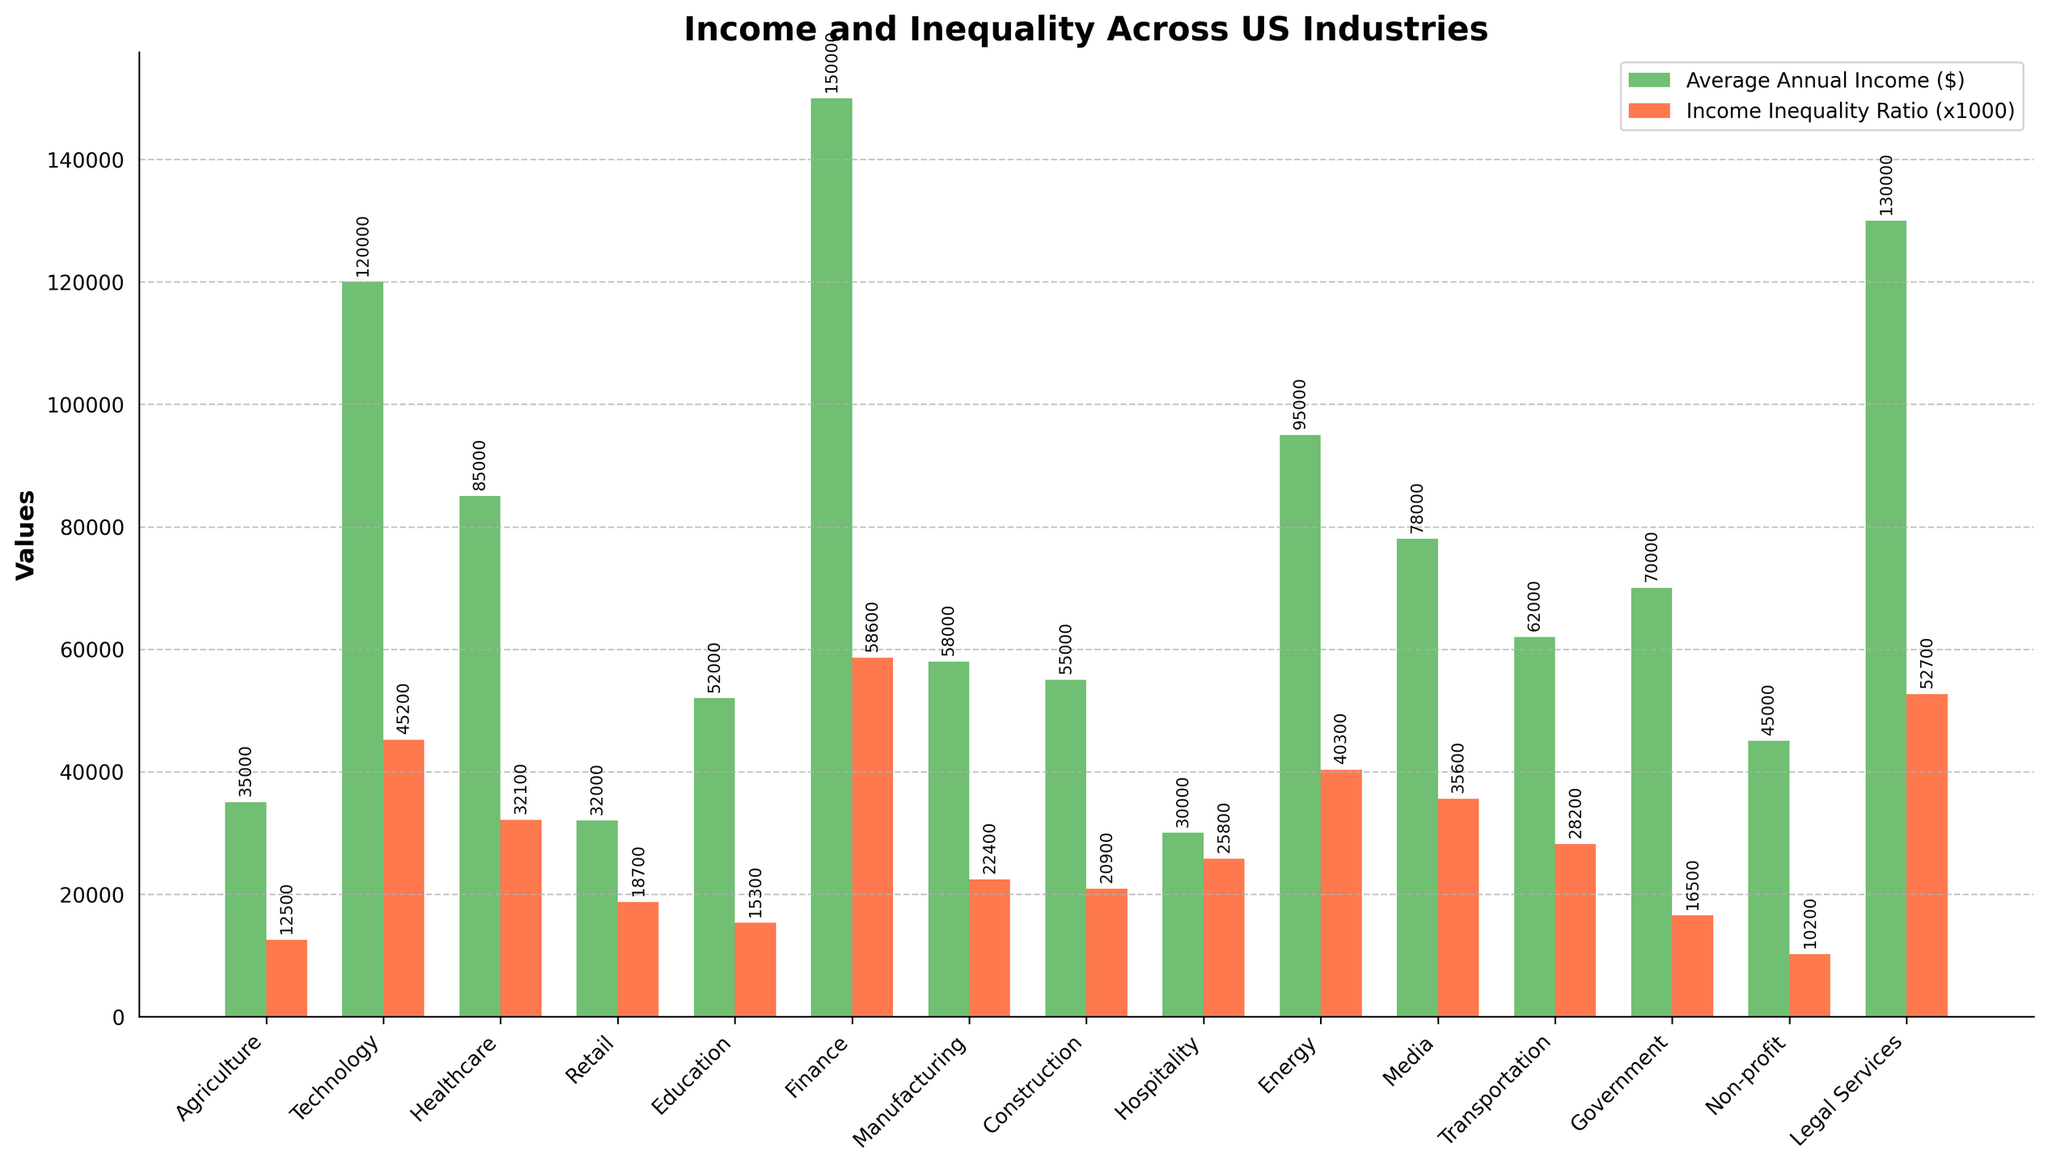Which industry has the highest average annual income? Look for the tallest green bar representing the average annual income. Technology industry has the highest bar indicating an average annual income of $120,000.
Answer: Technology Which industry shows the highest income inequality ratio? Look for the tallest red bar representing the income inequality ratio multiplied by 1000. Finance has the tallest red bar with an inequality ratio of 58.6.
Answer: Finance What is the difference in average annual income between the Technology and Retail industries? Find the green bars for Technology ($120,000) and Retail ($32,000), then subtract the Retail value from the Technology value. $120,000 - $32,000 = $88,000.
Answer: $88,000 Which industry has a higher income inequality, Energy or Media? Compare the heights of the red bars for Energy and Media. Energy's bar is higher with a ratio of 40.3, whereas Media has a ratio of 35.6.
Answer: Energy Is the income inequality ratio of Legal Services greater than that of Technology? Compare the heights of the red bars for Legal Services and Technology. Legal Services has a higher ratio of 52.7 compared to Technology's 45.2.
Answer: Yes Which industry has the lowest income inequality ratio? Look for the shortest red bar. Non-profit has the shortest red bar with a ratio of 10.2.
Answer: Non-profit What is the total combined average annual income of Agriculture and Healthcare industries? Add the average annual incomes of Agriculture ($35,000) and Healthcare ($85,000). $35,000 + $85,000 = $120,000.
Answer: $120,000 How does the income inequality in Education compare to that in Government? Compare the heights of the red bars for Education and Government. Education has a ratio of 15.3 and Government has 16.5. Education has a slightly lower income inequality.
Answer: Education Which industry has both low average annual income and high income inequality ratio? Identify bars where the green bar is low and the red bar (inequality) is comparatively high. Hospitality has low income ($30,000) and relatively high inequality (25.8).
Answer: Hospitality Out of all the industries, which has the most balanced (least extreme) difference between average annual income and income inequality ratio? Compare the relation between green and red bars across industries. Non-profit has the smallest disparity with low numbers in both metrics (Income: $45,000, Inequality: 10.2).
Answer: Non-profit 